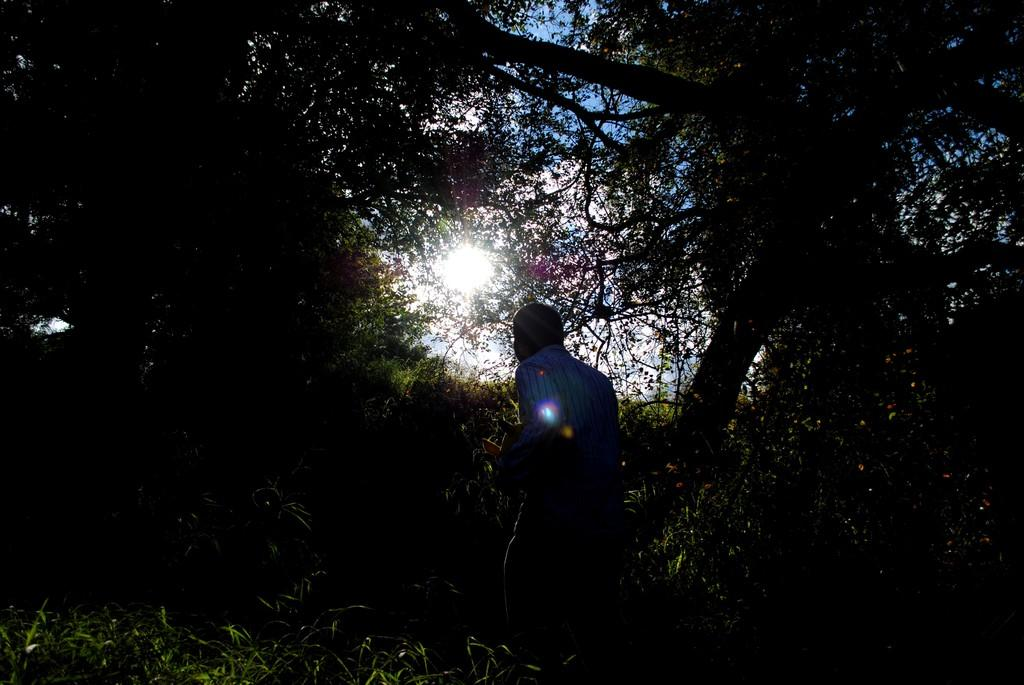What is the main subject of the image? There is a man standing in the image. What type of natural elements can be seen in the image? There are trees in the image. What part of the natural environment is visible in the image? The sky is visible in the image. How many plastic ladybugs are crawling on the man's shoulder in the image? There are no plastic ladybugs present in the image. 